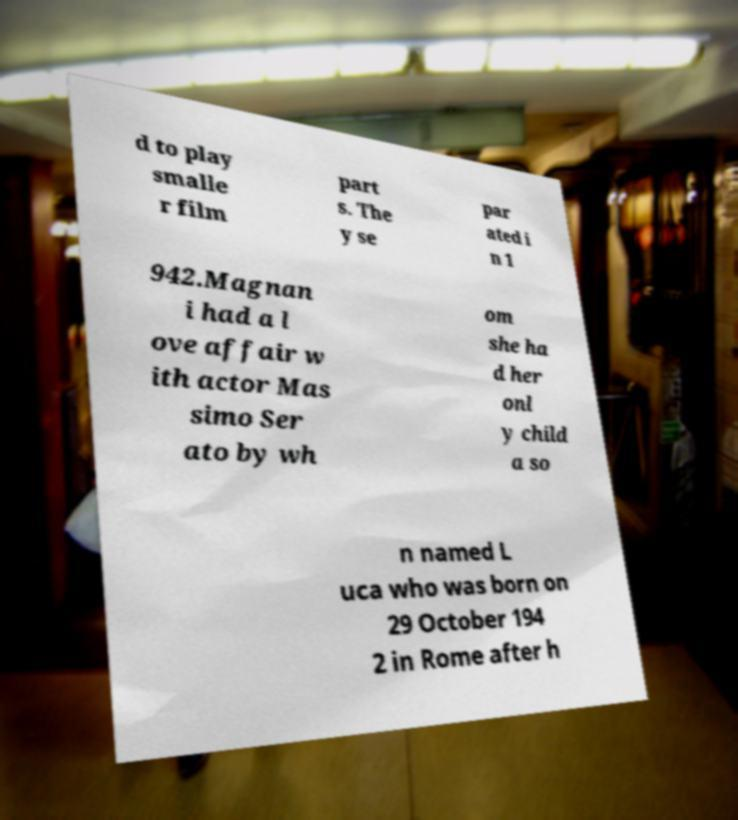There's text embedded in this image that I need extracted. Can you transcribe it verbatim? d to play smalle r film part s. The y se par ated i n 1 942.Magnan i had a l ove affair w ith actor Mas simo Ser ato by wh om she ha d her onl y child a so n named L uca who was born on 29 October 194 2 in Rome after h 